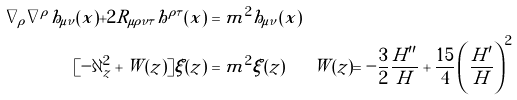<formula> <loc_0><loc_0><loc_500><loc_500>\nabla _ { \rho } \nabla ^ { \rho } h _ { \mu \nu } ( x ) + 2 R _ { \mu \rho \nu \tau } h ^ { \rho \tau } ( x ) & = m ^ { 2 } h _ { \mu \nu } ( x ) \\ [ - \partial _ { z } ^ { 2 } + W ( z ) ] \xi ( z ) & = m ^ { 2 } \xi ( z ) \quad \ \ W ( z ) = - \frac { 3 } { 2 } \frac { H ^ { \prime \prime } } { H } + \frac { 1 5 } { 4 } \left ( \frac { H ^ { \prime } } { H } \right ) ^ { 2 }</formula> 